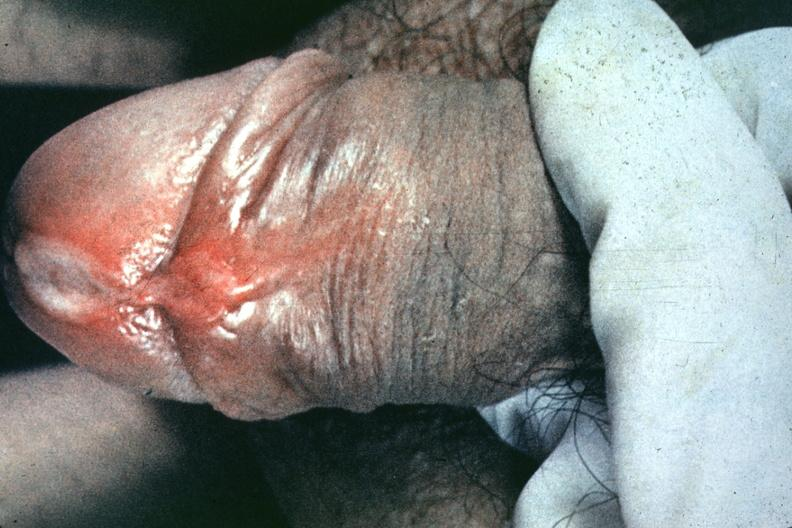s gangrene fingers present?
Answer the question using a single word or phrase. No 